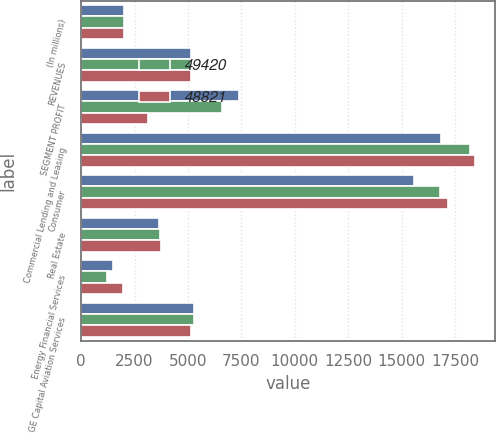<chart> <loc_0><loc_0><loc_500><loc_500><stacked_bar_chart><ecel><fcel>(In millions)<fcel>REVENUES<fcel>SEGMENT PROFIT<fcel>Commercial Lending and Leasing<fcel>Consumer<fcel>Real Estate<fcel>Energy Financial Services<fcel>GE Capital Aviation Services<nl><fcel>nan<fcel>2012<fcel>5127<fcel>7401<fcel>16857<fcel>15579<fcel>3654<fcel>1508<fcel>5294<nl><fcel>49420<fcel>2011<fcel>5127<fcel>6584<fcel>18178<fcel>16767<fcel>3712<fcel>1223<fcel>5262<nl><fcel>48821<fcel>2010<fcel>5127<fcel>3120<fcel>18447<fcel>17180<fcel>3744<fcel>1957<fcel>5127<nl></chart> 